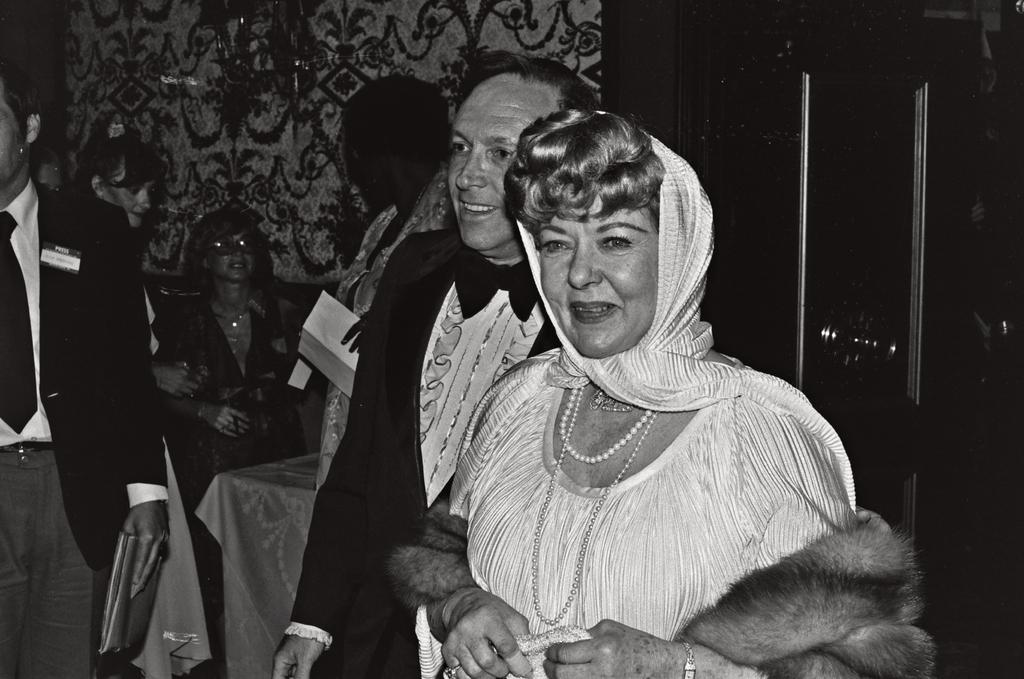What is the color scheme of the picture? The picture is black and white. How is the background of the picture depicted? The background of the picture is blurred. Can you describe the subjects in the picture? There are people in the picture, specifically a man and a woman. What are the man and the woman doing in the picture? The man and the woman are standing and smiling. What type of creature is present in the office depicted in the image? There is no office or creature present in the image; it is a black and white picture of a man and a woman standing and smiling. 